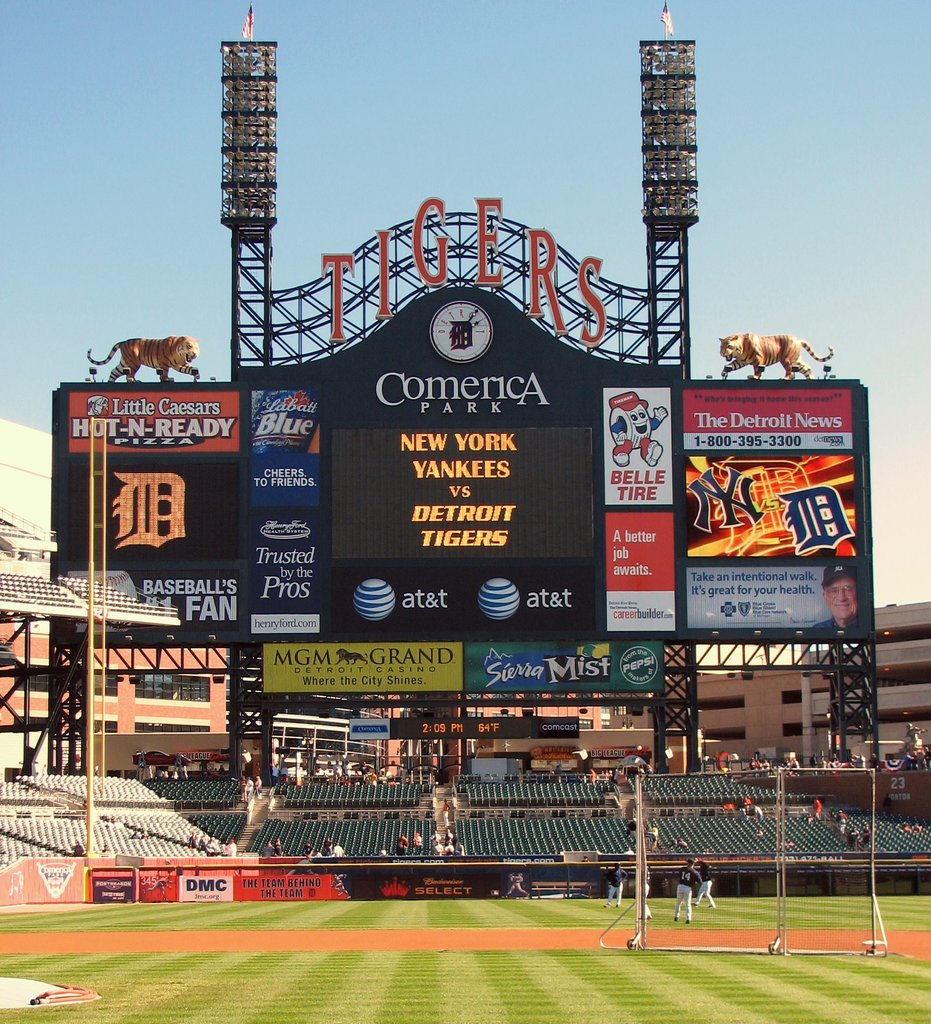Provide a one-sentence caption for the provided image. The scoreboard at Comerica Park brightly announces an exciting baseball match between the New York Yankees and the Detroit Tigers, capturing the spirit of the game with various sponsors and ads vividly displayed. 